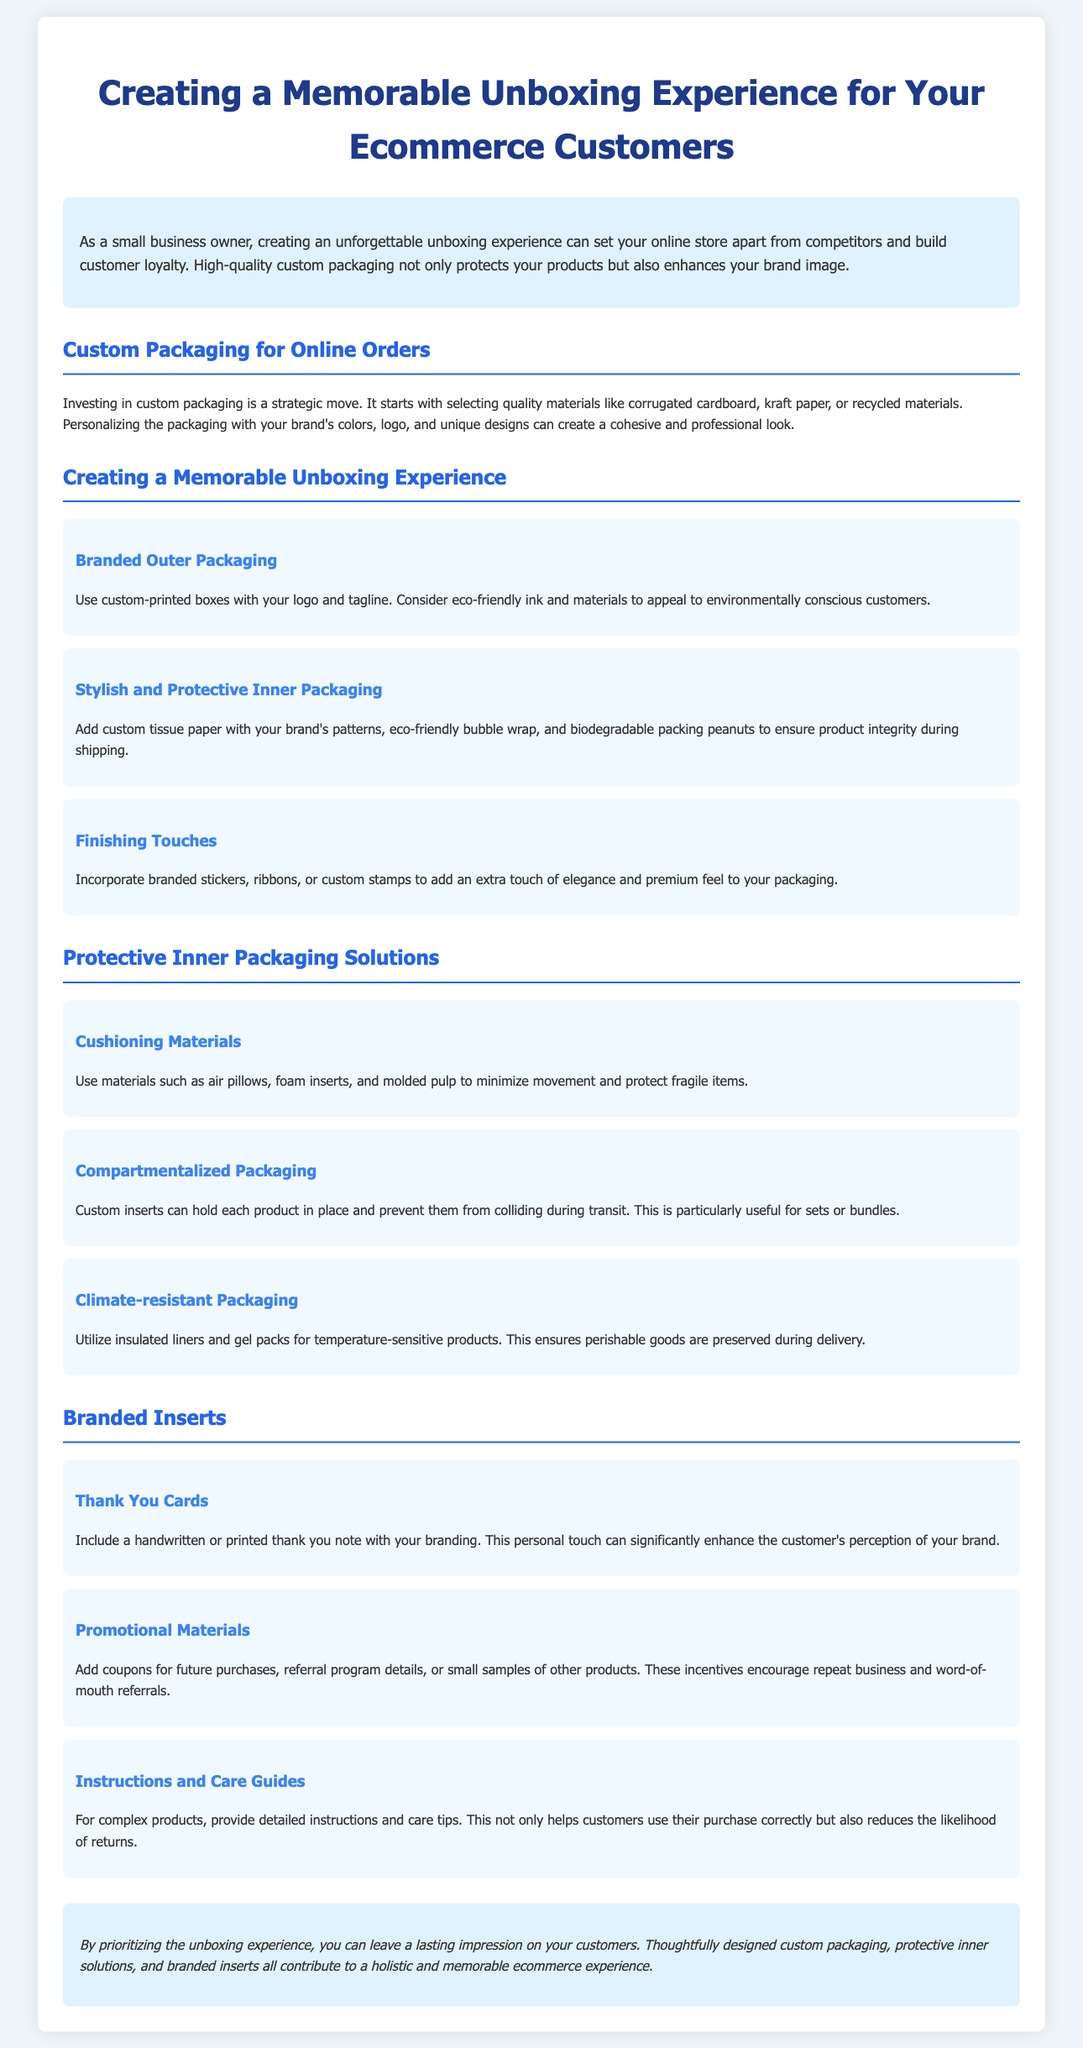What is the primary goal of custom packaging? The primary goal of custom packaging is to set your online store apart from competitors and build customer loyalty.
Answer: Build customer loyalty What is one material suggested for custom packaging? One suggested material for custom packaging in the document is corrugated cardboard.
Answer: Corrugated cardboard What can be included in branded outer packaging? Branded outer packaging can include custom-printed boxes with your logo and tagline.
Answer: Custom-printed boxes What type of packaging can minimize movement for fragile items? Cushioning materials such as air pillows can minimize movement for fragile items.
Answer: Air pillows What is a suggested finishing touch for packaging? A suggested finishing touch is incorporating branded stickers.
Answer: Branded stickers What should be included in thank you cards? Thank you cards should include either a handwritten or printed note.
Answer: Handwritten or printed note What could be a reason for using compartmentalized packaging? Compartmentalized packaging is particularly useful for keeping sets or bundles in place.
Answer: Keeping sets or bundles in place How do insulated liners help in packaging? Insulated liners help in preserving temperature-sensitive products during delivery.
Answer: Preserving temperature-sensitive products What type of materials can be included as promotional materials? Coupons for future purchases can be included as promotional materials.
Answer: Coupons for future purchases 